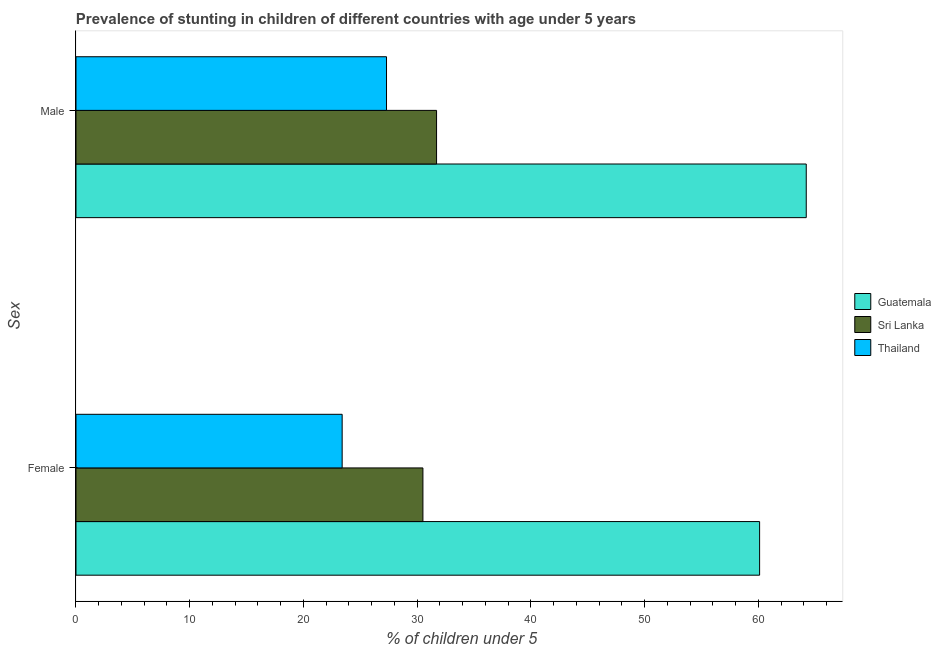How many groups of bars are there?
Offer a terse response. 2. How many bars are there on the 2nd tick from the top?
Make the answer very short. 3. What is the percentage of stunted male children in Guatemala?
Your response must be concise. 64.2. Across all countries, what is the maximum percentage of stunted male children?
Ensure brevity in your answer.  64.2. Across all countries, what is the minimum percentage of stunted male children?
Your response must be concise. 27.3. In which country was the percentage of stunted female children maximum?
Make the answer very short. Guatemala. In which country was the percentage of stunted male children minimum?
Give a very brief answer. Thailand. What is the total percentage of stunted female children in the graph?
Your response must be concise. 114. What is the difference between the percentage of stunted female children in Sri Lanka and that in Thailand?
Provide a succinct answer. 7.1. What is the difference between the percentage of stunted male children in Sri Lanka and the percentage of stunted female children in Guatemala?
Ensure brevity in your answer.  -28.4. What is the average percentage of stunted male children per country?
Provide a short and direct response. 41.07. What is the difference between the percentage of stunted female children and percentage of stunted male children in Sri Lanka?
Give a very brief answer. -1.2. What is the ratio of the percentage of stunted male children in Guatemala to that in Sri Lanka?
Ensure brevity in your answer.  2.03. What does the 2nd bar from the top in Male represents?
Ensure brevity in your answer.  Sri Lanka. What does the 1st bar from the bottom in Female represents?
Your response must be concise. Guatemala. How many bars are there?
Offer a very short reply. 6. Are all the bars in the graph horizontal?
Keep it short and to the point. Yes. How many countries are there in the graph?
Offer a terse response. 3. Does the graph contain any zero values?
Your answer should be very brief. No. Does the graph contain grids?
Make the answer very short. No. Where does the legend appear in the graph?
Provide a succinct answer. Center right. How are the legend labels stacked?
Offer a very short reply. Vertical. What is the title of the graph?
Your response must be concise. Prevalence of stunting in children of different countries with age under 5 years. Does "Iceland" appear as one of the legend labels in the graph?
Offer a terse response. No. What is the label or title of the X-axis?
Offer a terse response.  % of children under 5. What is the label or title of the Y-axis?
Offer a very short reply. Sex. What is the  % of children under 5 in Guatemala in Female?
Provide a succinct answer. 60.1. What is the  % of children under 5 in Sri Lanka in Female?
Your answer should be very brief. 30.5. What is the  % of children under 5 of Thailand in Female?
Provide a short and direct response. 23.4. What is the  % of children under 5 in Guatemala in Male?
Your answer should be very brief. 64.2. What is the  % of children under 5 in Sri Lanka in Male?
Make the answer very short. 31.7. What is the  % of children under 5 in Thailand in Male?
Offer a terse response. 27.3. Across all Sex, what is the maximum  % of children under 5 in Guatemala?
Offer a very short reply. 64.2. Across all Sex, what is the maximum  % of children under 5 in Sri Lanka?
Give a very brief answer. 31.7. Across all Sex, what is the maximum  % of children under 5 of Thailand?
Your response must be concise. 27.3. Across all Sex, what is the minimum  % of children under 5 in Guatemala?
Provide a short and direct response. 60.1. Across all Sex, what is the minimum  % of children under 5 in Sri Lanka?
Keep it short and to the point. 30.5. Across all Sex, what is the minimum  % of children under 5 in Thailand?
Provide a short and direct response. 23.4. What is the total  % of children under 5 of Guatemala in the graph?
Make the answer very short. 124.3. What is the total  % of children under 5 in Sri Lanka in the graph?
Offer a very short reply. 62.2. What is the total  % of children under 5 of Thailand in the graph?
Your response must be concise. 50.7. What is the difference between the  % of children under 5 in Thailand in Female and that in Male?
Keep it short and to the point. -3.9. What is the difference between the  % of children under 5 of Guatemala in Female and the  % of children under 5 of Sri Lanka in Male?
Your answer should be compact. 28.4. What is the difference between the  % of children under 5 of Guatemala in Female and the  % of children under 5 of Thailand in Male?
Ensure brevity in your answer.  32.8. What is the difference between the  % of children under 5 of Sri Lanka in Female and the  % of children under 5 of Thailand in Male?
Your answer should be very brief. 3.2. What is the average  % of children under 5 of Guatemala per Sex?
Keep it short and to the point. 62.15. What is the average  % of children under 5 in Sri Lanka per Sex?
Ensure brevity in your answer.  31.1. What is the average  % of children under 5 of Thailand per Sex?
Your answer should be very brief. 25.35. What is the difference between the  % of children under 5 in Guatemala and  % of children under 5 in Sri Lanka in Female?
Offer a very short reply. 29.6. What is the difference between the  % of children under 5 of Guatemala and  % of children under 5 of Thailand in Female?
Ensure brevity in your answer.  36.7. What is the difference between the  % of children under 5 of Guatemala and  % of children under 5 of Sri Lanka in Male?
Provide a short and direct response. 32.5. What is the difference between the  % of children under 5 of Guatemala and  % of children under 5 of Thailand in Male?
Your answer should be compact. 36.9. What is the ratio of the  % of children under 5 in Guatemala in Female to that in Male?
Provide a short and direct response. 0.94. What is the ratio of the  % of children under 5 of Sri Lanka in Female to that in Male?
Provide a short and direct response. 0.96. What is the ratio of the  % of children under 5 in Thailand in Female to that in Male?
Your answer should be compact. 0.86. What is the difference between the highest and the lowest  % of children under 5 in Guatemala?
Provide a succinct answer. 4.1. What is the difference between the highest and the lowest  % of children under 5 in Thailand?
Provide a short and direct response. 3.9. 